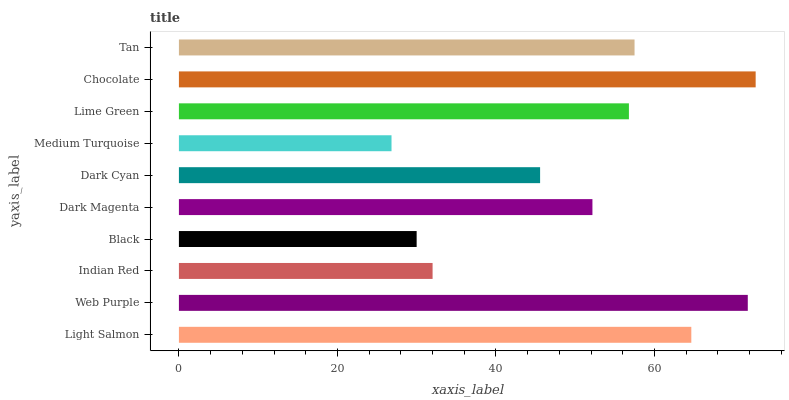Is Medium Turquoise the minimum?
Answer yes or no. Yes. Is Chocolate the maximum?
Answer yes or no. Yes. Is Web Purple the minimum?
Answer yes or no. No. Is Web Purple the maximum?
Answer yes or no. No. Is Web Purple greater than Light Salmon?
Answer yes or no. Yes. Is Light Salmon less than Web Purple?
Answer yes or no. Yes. Is Light Salmon greater than Web Purple?
Answer yes or no. No. Is Web Purple less than Light Salmon?
Answer yes or no. No. Is Lime Green the high median?
Answer yes or no. Yes. Is Dark Magenta the low median?
Answer yes or no. Yes. Is Web Purple the high median?
Answer yes or no. No. Is Web Purple the low median?
Answer yes or no. No. 